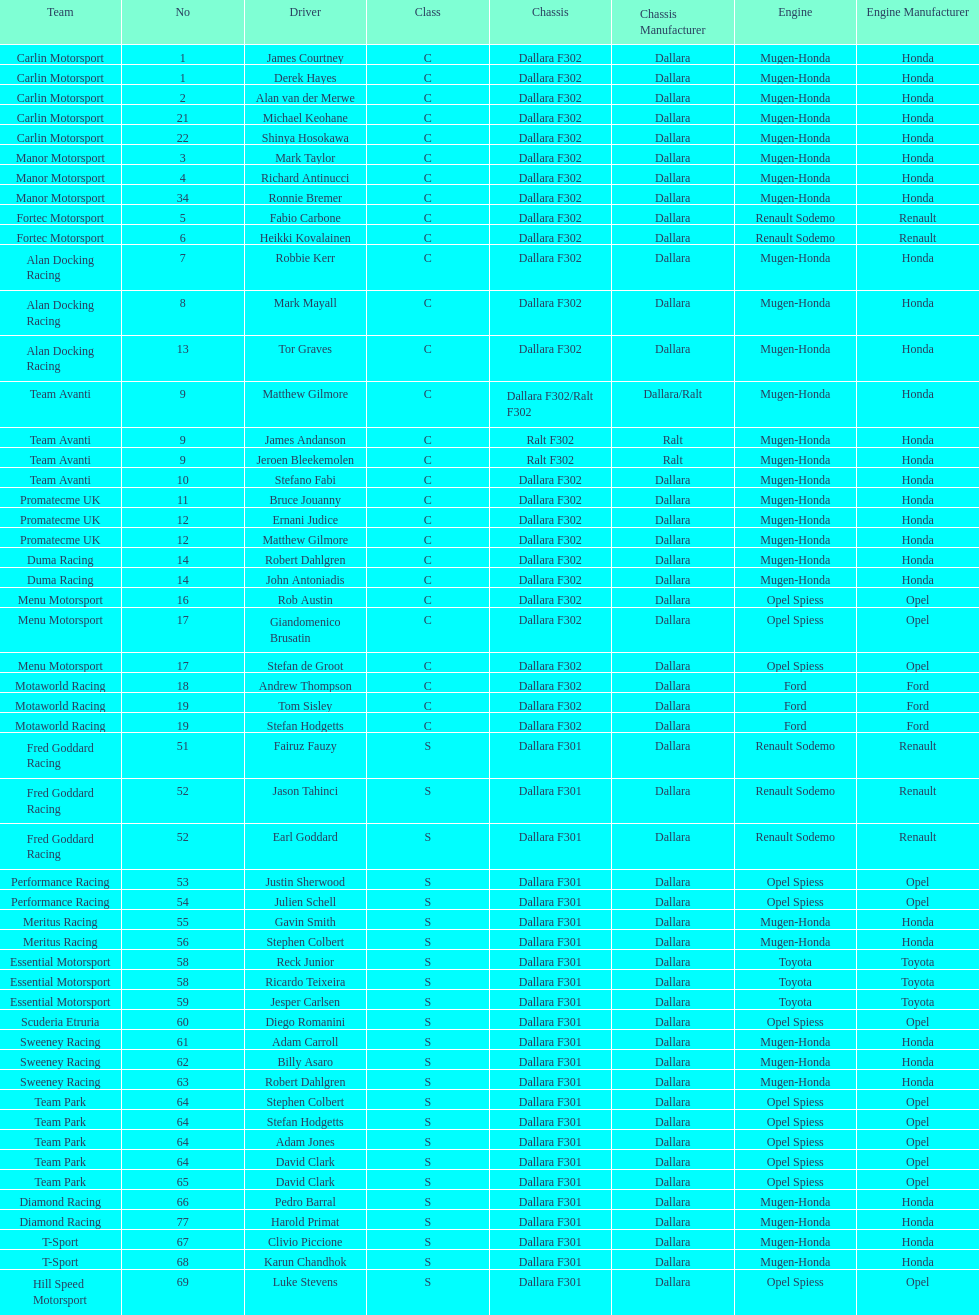The two drivers on t-sport are clivio piccione and what other driver? Karun Chandhok. 